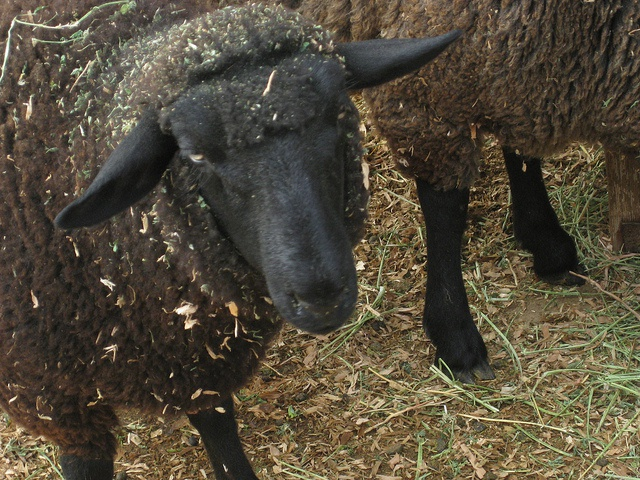Describe the objects in this image and their specific colors. I can see sheep in gray and black tones and sheep in brown, black, and gray tones in this image. 